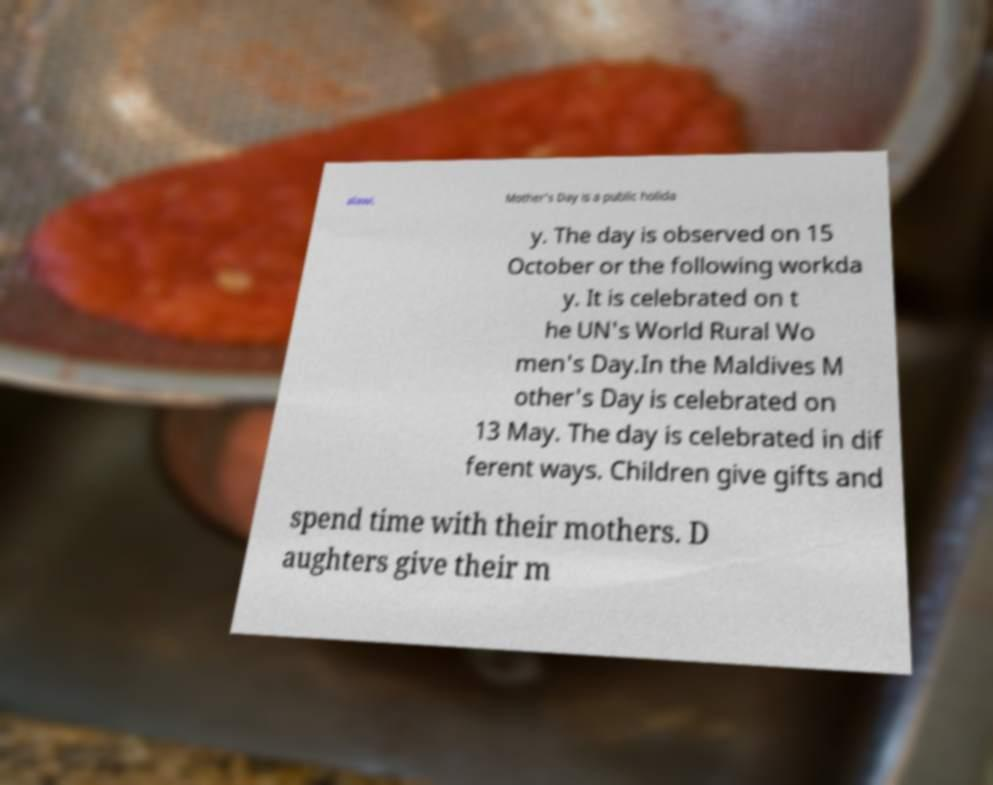What messages or text are displayed in this image? I need them in a readable, typed format. alawi. Mother's Day is a public holida y. The day is observed on 15 October or the following workda y. It is celebrated on t he UN's World Rural Wo men's Day.In the Maldives M other's Day is celebrated on 13 May. The day is celebrated in dif ferent ways. Children give gifts and spend time with their mothers. D aughters give their m 